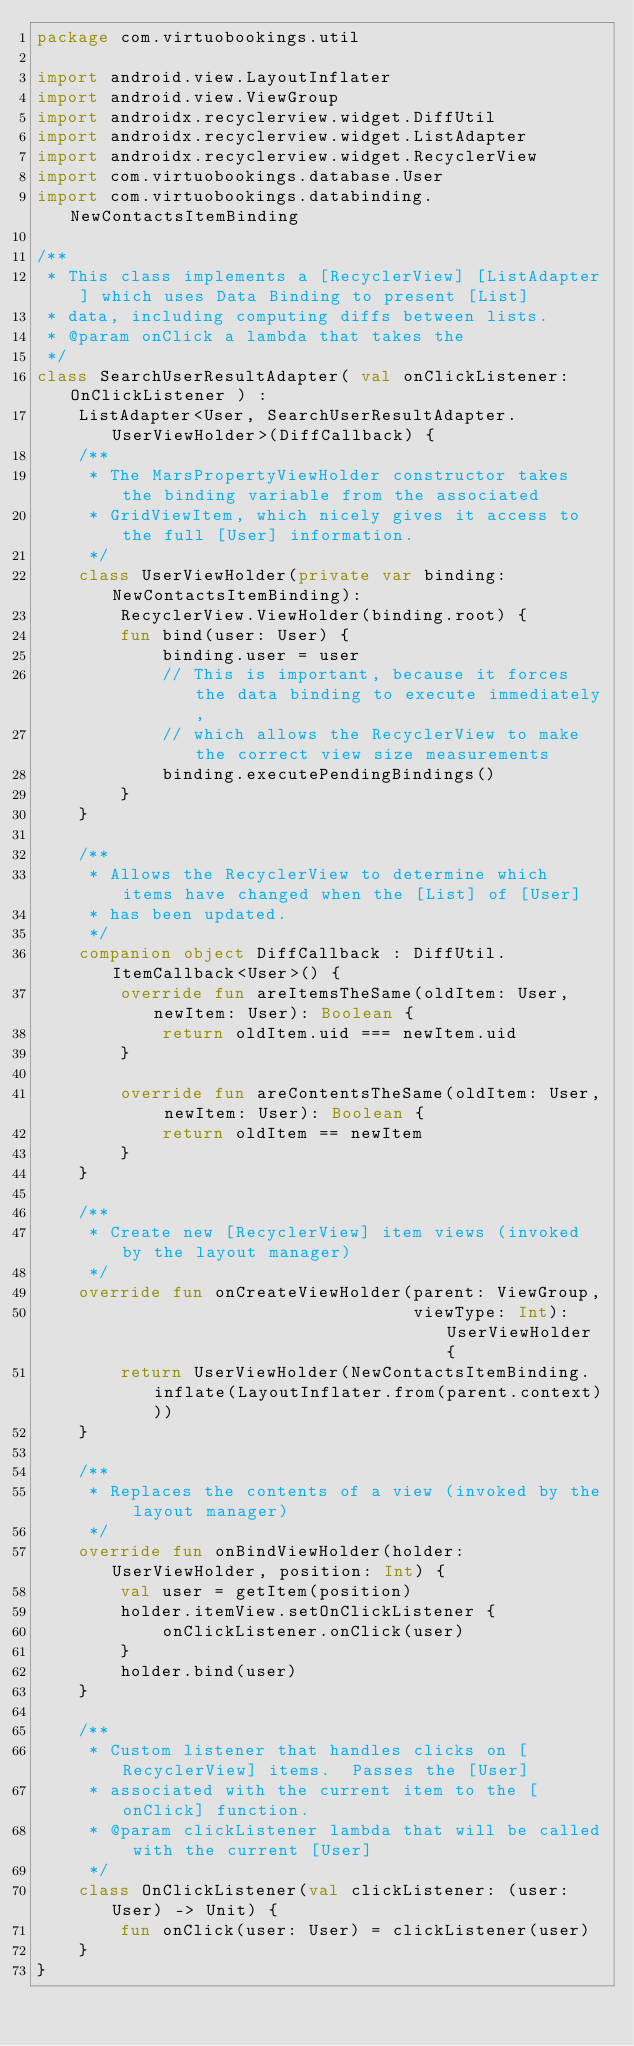Convert code to text. <code><loc_0><loc_0><loc_500><loc_500><_Kotlin_>package com.virtuobookings.util

import android.view.LayoutInflater
import android.view.ViewGroup
import androidx.recyclerview.widget.DiffUtil
import androidx.recyclerview.widget.ListAdapter
import androidx.recyclerview.widget.RecyclerView
import com.virtuobookings.database.User
import com.virtuobookings.databinding.NewContactsItemBinding

/**
 * This class implements a [RecyclerView] [ListAdapter] which uses Data Binding to present [List]
 * data, including computing diffs between lists.
 * @param onClick a lambda that takes the
 */
class SearchUserResultAdapter( val onClickListener: OnClickListener ) :
    ListAdapter<User, SearchUserResultAdapter.UserViewHolder>(DiffCallback) {
    /**
     * The MarsPropertyViewHolder constructor takes the binding variable from the associated
     * GridViewItem, which nicely gives it access to the full [User] information.
     */
    class UserViewHolder(private var binding: NewContactsItemBinding):
        RecyclerView.ViewHolder(binding.root) {
        fun bind(user: User) {
            binding.user = user
            // This is important, because it forces the data binding to execute immediately,
            // which allows the RecyclerView to make the correct view size measurements
            binding.executePendingBindings()
        }
    }

    /**
     * Allows the RecyclerView to determine which items have changed when the [List] of [User]
     * has been updated.
     */
    companion object DiffCallback : DiffUtil.ItemCallback<User>() {
        override fun areItemsTheSame(oldItem: User, newItem: User): Boolean {
            return oldItem.uid === newItem.uid
        }

        override fun areContentsTheSame(oldItem: User, newItem: User): Boolean {
            return oldItem == newItem
        }
    }

    /**
     * Create new [RecyclerView] item views (invoked by the layout manager)
     */
    override fun onCreateViewHolder(parent: ViewGroup,
                                    viewType: Int): UserViewHolder {
        return UserViewHolder(NewContactsItemBinding.inflate(LayoutInflater.from(parent.context)))
    }

    /**
     * Replaces the contents of a view (invoked by the layout manager)
     */
    override fun onBindViewHolder(holder: UserViewHolder, position: Int) {
        val user = getItem(position)
        holder.itemView.setOnClickListener {
            onClickListener.onClick(user)
        }
        holder.bind(user)
    }

    /**
     * Custom listener that handles clicks on [RecyclerView] items.  Passes the [User]
     * associated with the current item to the [onClick] function.
     * @param clickListener lambda that will be called with the current [User]
     */
    class OnClickListener(val clickListener: (user: User) -> Unit) {
        fun onClick(user: User) = clickListener(user)
    }
}
</code> 